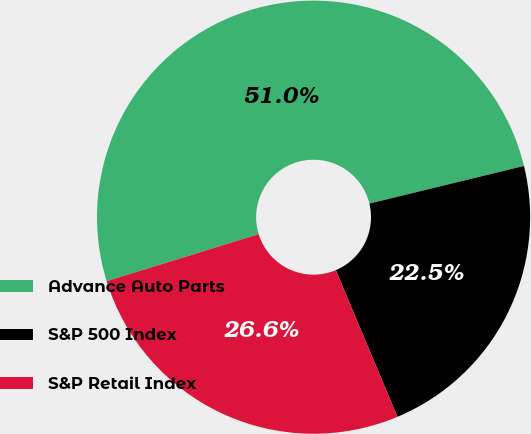Convert chart. <chart><loc_0><loc_0><loc_500><loc_500><pie_chart><fcel>Advance Auto Parts<fcel>S&P 500 Index<fcel>S&P Retail Index<nl><fcel>50.98%<fcel>22.47%<fcel>26.56%<nl></chart> 